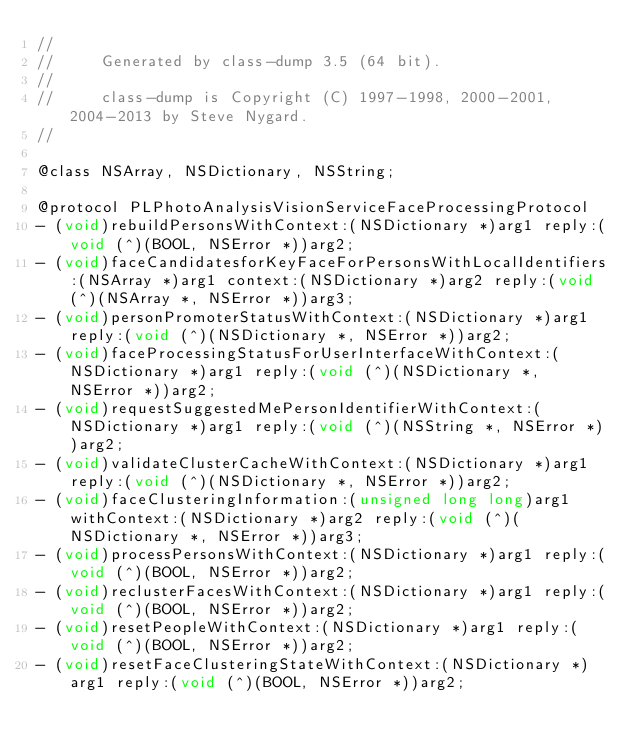<code> <loc_0><loc_0><loc_500><loc_500><_C_>//
//     Generated by class-dump 3.5 (64 bit).
//
//     class-dump is Copyright (C) 1997-1998, 2000-2001, 2004-2013 by Steve Nygard.
//

@class NSArray, NSDictionary, NSString;

@protocol PLPhotoAnalysisVisionServiceFaceProcessingProtocol
- (void)rebuildPersonsWithContext:(NSDictionary *)arg1 reply:(void (^)(BOOL, NSError *))arg2;
- (void)faceCandidatesforKeyFaceForPersonsWithLocalIdentifiers:(NSArray *)arg1 context:(NSDictionary *)arg2 reply:(void (^)(NSArray *, NSError *))arg3;
- (void)personPromoterStatusWithContext:(NSDictionary *)arg1 reply:(void (^)(NSDictionary *, NSError *))arg2;
- (void)faceProcessingStatusForUserInterfaceWithContext:(NSDictionary *)arg1 reply:(void (^)(NSDictionary *, NSError *))arg2;
- (void)requestSuggestedMePersonIdentifierWithContext:(NSDictionary *)arg1 reply:(void (^)(NSString *, NSError *))arg2;
- (void)validateClusterCacheWithContext:(NSDictionary *)arg1 reply:(void (^)(NSDictionary *, NSError *))arg2;
- (void)faceClusteringInformation:(unsigned long long)arg1 withContext:(NSDictionary *)arg2 reply:(void (^)(NSDictionary *, NSError *))arg3;
- (void)processPersonsWithContext:(NSDictionary *)arg1 reply:(void (^)(BOOL, NSError *))arg2;
- (void)reclusterFacesWithContext:(NSDictionary *)arg1 reply:(void (^)(BOOL, NSError *))arg2;
- (void)resetPeopleWithContext:(NSDictionary *)arg1 reply:(void (^)(BOOL, NSError *))arg2;
- (void)resetFaceClusteringStateWithContext:(NSDictionary *)arg1 reply:(void (^)(BOOL, NSError *))arg2;</code> 